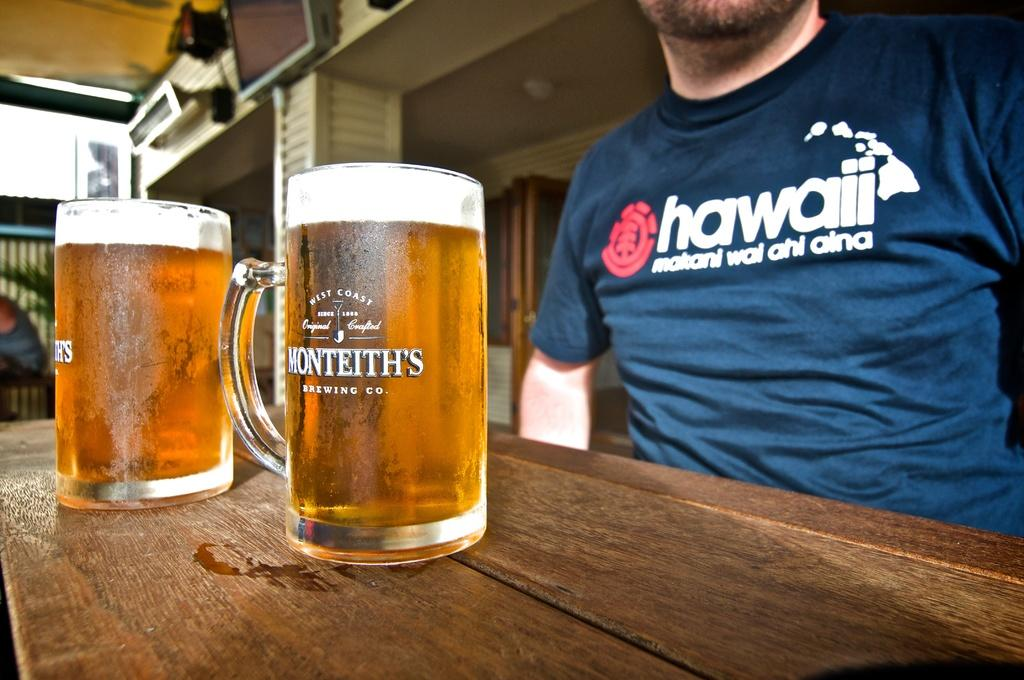<image>
Describe the image concisely. A man sits in front of two pints of beer; the word Hawaii is on his shirt. 